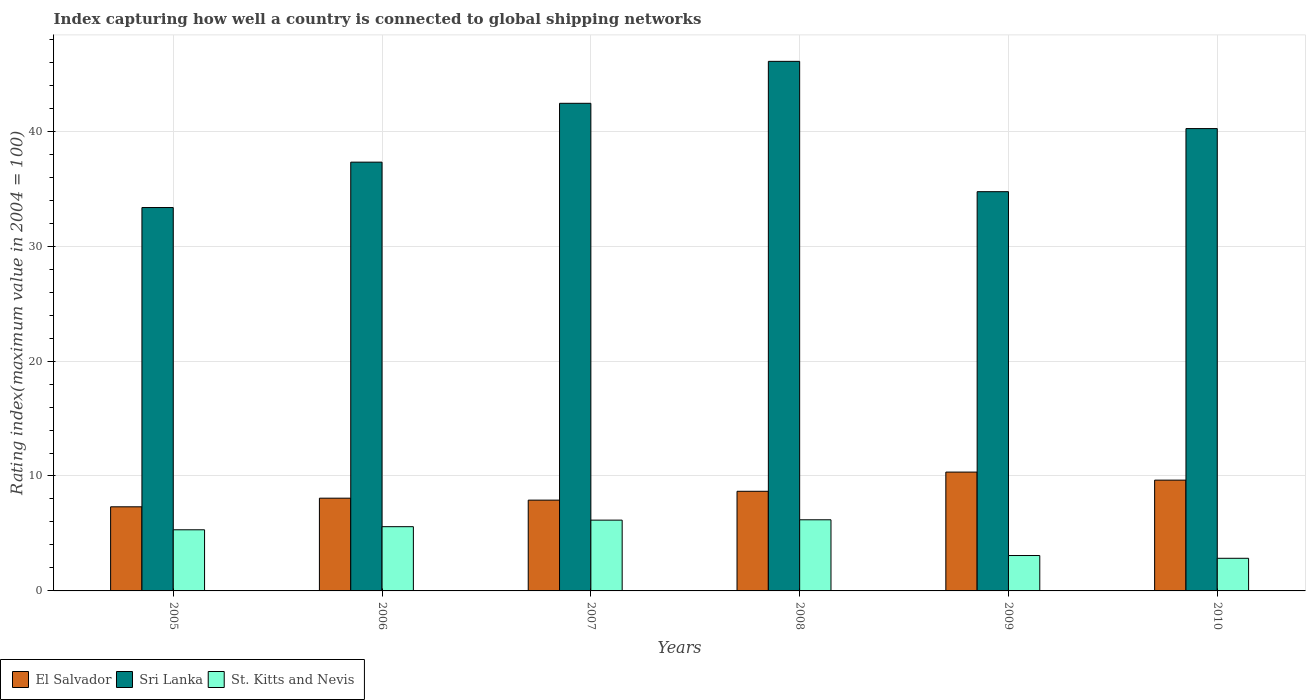How many different coloured bars are there?
Provide a succinct answer. 3. How many groups of bars are there?
Offer a terse response. 6. How many bars are there on the 3rd tick from the left?
Offer a terse response. 3. How many bars are there on the 1st tick from the right?
Offer a very short reply. 3. What is the label of the 1st group of bars from the left?
Make the answer very short. 2005. In how many cases, is the number of bars for a given year not equal to the number of legend labels?
Offer a terse response. 0. What is the rating index in St. Kitts and Nevis in 2008?
Provide a succinct answer. 6.19. Across all years, what is the maximum rating index in Sri Lanka?
Make the answer very short. 46.08. Across all years, what is the minimum rating index in Sri Lanka?
Make the answer very short. 33.36. In which year was the rating index in St. Kitts and Nevis maximum?
Offer a terse response. 2008. In which year was the rating index in Sri Lanka minimum?
Make the answer very short. 2005. What is the total rating index in El Salvador in the graph?
Your answer should be compact. 51.94. What is the difference between the rating index in Sri Lanka in 2009 and that in 2010?
Give a very brief answer. -5.49. What is the difference between the rating index in El Salvador in 2010 and the rating index in St. Kitts and Nevis in 2006?
Ensure brevity in your answer.  4.05. What is the average rating index in Sri Lanka per year?
Provide a short and direct response. 39.02. In the year 2008, what is the difference between the rating index in Sri Lanka and rating index in St. Kitts and Nevis?
Provide a short and direct response. 39.89. What is the ratio of the rating index in St. Kitts and Nevis in 2006 to that in 2010?
Provide a succinct answer. 1.97. Is the difference between the rating index in Sri Lanka in 2005 and 2006 greater than the difference between the rating index in St. Kitts and Nevis in 2005 and 2006?
Your answer should be compact. No. What is the difference between the highest and the second highest rating index in St. Kitts and Nevis?
Make the answer very short. 0.03. What is the difference between the highest and the lowest rating index in Sri Lanka?
Provide a succinct answer. 12.72. In how many years, is the rating index in St. Kitts and Nevis greater than the average rating index in St. Kitts and Nevis taken over all years?
Provide a succinct answer. 4. What does the 1st bar from the left in 2007 represents?
Ensure brevity in your answer.  El Salvador. What does the 3rd bar from the right in 2009 represents?
Provide a short and direct response. El Salvador. How many bars are there?
Offer a terse response. 18. Are all the bars in the graph horizontal?
Offer a terse response. No. Are the values on the major ticks of Y-axis written in scientific E-notation?
Keep it short and to the point. No. Does the graph contain any zero values?
Provide a succinct answer. No. How many legend labels are there?
Provide a short and direct response. 3. What is the title of the graph?
Offer a terse response. Index capturing how well a country is connected to global shipping networks. What is the label or title of the Y-axis?
Give a very brief answer. Rating index(maximum value in 2004 = 100). What is the Rating index(maximum value in 2004 = 100) in El Salvador in 2005?
Offer a very short reply. 7.32. What is the Rating index(maximum value in 2004 = 100) in Sri Lanka in 2005?
Make the answer very short. 33.36. What is the Rating index(maximum value in 2004 = 100) in St. Kitts and Nevis in 2005?
Keep it short and to the point. 5.32. What is the Rating index(maximum value in 2004 = 100) in El Salvador in 2006?
Make the answer very short. 8.07. What is the Rating index(maximum value in 2004 = 100) in Sri Lanka in 2006?
Offer a very short reply. 37.31. What is the Rating index(maximum value in 2004 = 100) in St. Kitts and Nevis in 2006?
Provide a short and direct response. 5.59. What is the Rating index(maximum value in 2004 = 100) of Sri Lanka in 2007?
Your answer should be very brief. 42.43. What is the Rating index(maximum value in 2004 = 100) in St. Kitts and Nevis in 2007?
Give a very brief answer. 6.16. What is the Rating index(maximum value in 2004 = 100) in El Salvador in 2008?
Give a very brief answer. 8.67. What is the Rating index(maximum value in 2004 = 100) in Sri Lanka in 2008?
Give a very brief answer. 46.08. What is the Rating index(maximum value in 2004 = 100) of St. Kitts and Nevis in 2008?
Give a very brief answer. 6.19. What is the Rating index(maximum value in 2004 = 100) in El Salvador in 2009?
Offer a very short reply. 10.34. What is the Rating index(maximum value in 2004 = 100) in Sri Lanka in 2009?
Your answer should be compact. 34.74. What is the Rating index(maximum value in 2004 = 100) of St. Kitts and Nevis in 2009?
Your answer should be compact. 3.08. What is the Rating index(maximum value in 2004 = 100) in El Salvador in 2010?
Ensure brevity in your answer.  9.64. What is the Rating index(maximum value in 2004 = 100) of Sri Lanka in 2010?
Keep it short and to the point. 40.23. What is the Rating index(maximum value in 2004 = 100) in St. Kitts and Nevis in 2010?
Offer a very short reply. 2.84. Across all years, what is the maximum Rating index(maximum value in 2004 = 100) in El Salvador?
Your answer should be compact. 10.34. Across all years, what is the maximum Rating index(maximum value in 2004 = 100) of Sri Lanka?
Offer a very short reply. 46.08. Across all years, what is the maximum Rating index(maximum value in 2004 = 100) in St. Kitts and Nevis?
Your response must be concise. 6.19. Across all years, what is the minimum Rating index(maximum value in 2004 = 100) in El Salvador?
Offer a terse response. 7.32. Across all years, what is the minimum Rating index(maximum value in 2004 = 100) in Sri Lanka?
Give a very brief answer. 33.36. Across all years, what is the minimum Rating index(maximum value in 2004 = 100) in St. Kitts and Nevis?
Give a very brief answer. 2.84. What is the total Rating index(maximum value in 2004 = 100) in El Salvador in the graph?
Offer a very short reply. 51.94. What is the total Rating index(maximum value in 2004 = 100) of Sri Lanka in the graph?
Provide a succinct answer. 234.15. What is the total Rating index(maximum value in 2004 = 100) in St. Kitts and Nevis in the graph?
Provide a short and direct response. 29.18. What is the difference between the Rating index(maximum value in 2004 = 100) of El Salvador in 2005 and that in 2006?
Provide a succinct answer. -0.75. What is the difference between the Rating index(maximum value in 2004 = 100) in Sri Lanka in 2005 and that in 2006?
Give a very brief answer. -3.95. What is the difference between the Rating index(maximum value in 2004 = 100) of St. Kitts and Nevis in 2005 and that in 2006?
Offer a very short reply. -0.27. What is the difference between the Rating index(maximum value in 2004 = 100) of El Salvador in 2005 and that in 2007?
Offer a very short reply. -0.58. What is the difference between the Rating index(maximum value in 2004 = 100) in Sri Lanka in 2005 and that in 2007?
Make the answer very short. -9.07. What is the difference between the Rating index(maximum value in 2004 = 100) of St. Kitts and Nevis in 2005 and that in 2007?
Offer a very short reply. -0.84. What is the difference between the Rating index(maximum value in 2004 = 100) in El Salvador in 2005 and that in 2008?
Offer a terse response. -1.35. What is the difference between the Rating index(maximum value in 2004 = 100) of Sri Lanka in 2005 and that in 2008?
Give a very brief answer. -12.72. What is the difference between the Rating index(maximum value in 2004 = 100) of St. Kitts and Nevis in 2005 and that in 2008?
Your response must be concise. -0.87. What is the difference between the Rating index(maximum value in 2004 = 100) in El Salvador in 2005 and that in 2009?
Offer a very short reply. -3.02. What is the difference between the Rating index(maximum value in 2004 = 100) of Sri Lanka in 2005 and that in 2009?
Give a very brief answer. -1.38. What is the difference between the Rating index(maximum value in 2004 = 100) in St. Kitts and Nevis in 2005 and that in 2009?
Ensure brevity in your answer.  2.24. What is the difference between the Rating index(maximum value in 2004 = 100) in El Salvador in 2005 and that in 2010?
Your answer should be very brief. -2.32. What is the difference between the Rating index(maximum value in 2004 = 100) in Sri Lanka in 2005 and that in 2010?
Provide a succinct answer. -6.87. What is the difference between the Rating index(maximum value in 2004 = 100) in St. Kitts and Nevis in 2005 and that in 2010?
Provide a succinct answer. 2.48. What is the difference between the Rating index(maximum value in 2004 = 100) in El Salvador in 2006 and that in 2007?
Your response must be concise. 0.17. What is the difference between the Rating index(maximum value in 2004 = 100) in Sri Lanka in 2006 and that in 2007?
Your answer should be compact. -5.12. What is the difference between the Rating index(maximum value in 2004 = 100) of St. Kitts and Nevis in 2006 and that in 2007?
Offer a very short reply. -0.57. What is the difference between the Rating index(maximum value in 2004 = 100) of El Salvador in 2006 and that in 2008?
Give a very brief answer. -0.6. What is the difference between the Rating index(maximum value in 2004 = 100) of Sri Lanka in 2006 and that in 2008?
Your response must be concise. -8.77. What is the difference between the Rating index(maximum value in 2004 = 100) of St. Kitts and Nevis in 2006 and that in 2008?
Give a very brief answer. -0.6. What is the difference between the Rating index(maximum value in 2004 = 100) of El Salvador in 2006 and that in 2009?
Your response must be concise. -2.27. What is the difference between the Rating index(maximum value in 2004 = 100) in Sri Lanka in 2006 and that in 2009?
Give a very brief answer. 2.57. What is the difference between the Rating index(maximum value in 2004 = 100) in St. Kitts and Nevis in 2006 and that in 2009?
Provide a short and direct response. 2.51. What is the difference between the Rating index(maximum value in 2004 = 100) in El Salvador in 2006 and that in 2010?
Your answer should be compact. -1.57. What is the difference between the Rating index(maximum value in 2004 = 100) in Sri Lanka in 2006 and that in 2010?
Your answer should be very brief. -2.92. What is the difference between the Rating index(maximum value in 2004 = 100) in St. Kitts and Nevis in 2006 and that in 2010?
Offer a very short reply. 2.75. What is the difference between the Rating index(maximum value in 2004 = 100) of El Salvador in 2007 and that in 2008?
Keep it short and to the point. -0.77. What is the difference between the Rating index(maximum value in 2004 = 100) in Sri Lanka in 2007 and that in 2008?
Ensure brevity in your answer.  -3.65. What is the difference between the Rating index(maximum value in 2004 = 100) in St. Kitts and Nevis in 2007 and that in 2008?
Your answer should be compact. -0.03. What is the difference between the Rating index(maximum value in 2004 = 100) of El Salvador in 2007 and that in 2009?
Your answer should be very brief. -2.44. What is the difference between the Rating index(maximum value in 2004 = 100) of Sri Lanka in 2007 and that in 2009?
Keep it short and to the point. 7.69. What is the difference between the Rating index(maximum value in 2004 = 100) in St. Kitts and Nevis in 2007 and that in 2009?
Offer a terse response. 3.08. What is the difference between the Rating index(maximum value in 2004 = 100) of El Salvador in 2007 and that in 2010?
Your response must be concise. -1.74. What is the difference between the Rating index(maximum value in 2004 = 100) in Sri Lanka in 2007 and that in 2010?
Provide a short and direct response. 2.2. What is the difference between the Rating index(maximum value in 2004 = 100) in St. Kitts and Nevis in 2007 and that in 2010?
Make the answer very short. 3.32. What is the difference between the Rating index(maximum value in 2004 = 100) of El Salvador in 2008 and that in 2009?
Keep it short and to the point. -1.67. What is the difference between the Rating index(maximum value in 2004 = 100) of Sri Lanka in 2008 and that in 2009?
Offer a terse response. 11.34. What is the difference between the Rating index(maximum value in 2004 = 100) in St. Kitts and Nevis in 2008 and that in 2009?
Your answer should be compact. 3.11. What is the difference between the Rating index(maximum value in 2004 = 100) of El Salvador in 2008 and that in 2010?
Make the answer very short. -0.97. What is the difference between the Rating index(maximum value in 2004 = 100) in Sri Lanka in 2008 and that in 2010?
Give a very brief answer. 5.85. What is the difference between the Rating index(maximum value in 2004 = 100) of St. Kitts and Nevis in 2008 and that in 2010?
Offer a very short reply. 3.35. What is the difference between the Rating index(maximum value in 2004 = 100) in El Salvador in 2009 and that in 2010?
Your response must be concise. 0.7. What is the difference between the Rating index(maximum value in 2004 = 100) of Sri Lanka in 2009 and that in 2010?
Your answer should be compact. -5.49. What is the difference between the Rating index(maximum value in 2004 = 100) of St. Kitts and Nevis in 2009 and that in 2010?
Offer a terse response. 0.24. What is the difference between the Rating index(maximum value in 2004 = 100) of El Salvador in 2005 and the Rating index(maximum value in 2004 = 100) of Sri Lanka in 2006?
Your answer should be compact. -29.99. What is the difference between the Rating index(maximum value in 2004 = 100) in El Salvador in 2005 and the Rating index(maximum value in 2004 = 100) in St. Kitts and Nevis in 2006?
Offer a terse response. 1.73. What is the difference between the Rating index(maximum value in 2004 = 100) in Sri Lanka in 2005 and the Rating index(maximum value in 2004 = 100) in St. Kitts and Nevis in 2006?
Your response must be concise. 27.77. What is the difference between the Rating index(maximum value in 2004 = 100) in El Salvador in 2005 and the Rating index(maximum value in 2004 = 100) in Sri Lanka in 2007?
Give a very brief answer. -35.11. What is the difference between the Rating index(maximum value in 2004 = 100) of El Salvador in 2005 and the Rating index(maximum value in 2004 = 100) of St. Kitts and Nevis in 2007?
Provide a short and direct response. 1.16. What is the difference between the Rating index(maximum value in 2004 = 100) of Sri Lanka in 2005 and the Rating index(maximum value in 2004 = 100) of St. Kitts and Nevis in 2007?
Keep it short and to the point. 27.2. What is the difference between the Rating index(maximum value in 2004 = 100) in El Salvador in 2005 and the Rating index(maximum value in 2004 = 100) in Sri Lanka in 2008?
Provide a short and direct response. -38.76. What is the difference between the Rating index(maximum value in 2004 = 100) in El Salvador in 2005 and the Rating index(maximum value in 2004 = 100) in St. Kitts and Nevis in 2008?
Ensure brevity in your answer.  1.13. What is the difference between the Rating index(maximum value in 2004 = 100) in Sri Lanka in 2005 and the Rating index(maximum value in 2004 = 100) in St. Kitts and Nevis in 2008?
Your answer should be very brief. 27.17. What is the difference between the Rating index(maximum value in 2004 = 100) in El Salvador in 2005 and the Rating index(maximum value in 2004 = 100) in Sri Lanka in 2009?
Provide a short and direct response. -27.42. What is the difference between the Rating index(maximum value in 2004 = 100) in El Salvador in 2005 and the Rating index(maximum value in 2004 = 100) in St. Kitts and Nevis in 2009?
Offer a very short reply. 4.24. What is the difference between the Rating index(maximum value in 2004 = 100) of Sri Lanka in 2005 and the Rating index(maximum value in 2004 = 100) of St. Kitts and Nevis in 2009?
Your response must be concise. 30.28. What is the difference between the Rating index(maximum value in 2004 = 100) in El Salvador in 2005 and the Rating index(maximum value in 2004 = 100) in Sri Lanka in 2010?
Your answer should be very brief. -32.91. What is the difference between the Rating index(maximum value in 2004 = 100) in El Salvador in 2005 and the Rating index(maximum value in 2004 = 100) in St. Kitts and Nevis in 2010?
Provide a short and direct response. 4.48. What is the difference between the Rating index(maximum value in 2004 = 100) in Sri Lanka in 2005 and the Rating index(maximum value in 2004 = 100) in St. Kitts and Nevis in 2010?
Ensure brevity in your answer.  30.52. What is the difference between the Rating index(maximum value in 2004 = 100) in El Salvador in 2006 and the Rating index(maximum value in 2004 = 100) in Sri Lanka in 2007?
Ensure brevity in your answer.  -34.36. What is the difference between the Rating index(maximum value in 2004 = 100) in El Salvador in 2006 and the Rating index(maximum value in 2004 = 100) in St. Kitts and Nevis in 2007?
Provide a succinct answer. 1.91. What is the difference between the Rating index(maximum value in 2004 = 100) in Sri Lanka in 2006 and the Rating index(maximum value in 2004 = 100) in St. Kitts and Nevis in 2007?
Provide a succinct answer. 31.15. What is the difference between the Rating index(maximum value in 2004 = 100) in El Salvador in 2006 and the Rating index(maximum value in 2004 = 100) in Sri Lanka in 2008?
Your response must be concise. -38.01. What is the difference between the Rating index(maximum value in 2004 = 100) of El Salvador in 2006 and the Rating index(maximum value in 2004 = 100) of St. Kitts and Nevis in 2008?
Your response must be concise. 1.88. What is the difference between the Rating index(maximum value in 2004 = 100) of Sri Lanka in 2006 and the Rating index(maximum value in 2004 = 100) of St. Kitts and Nevis in 2008?
Give a very brief answer. 31.12. What is the difference between the Rating index(maximum value in 2004 = 100) of El Salvador in 2006 and the Rating index(maximum value in 2004 = 100) of Sri Lanka in 2009?
Give a very brief answer. -26.67. What is the difference between the Rating index(maximum value in 2004 = 100) of El Salvador in 2006 and the Rating index(maximum value in 2004 = 100) of St. Kitts and Nevis in 2009?
Offer a very short reply. 4.99. What is the difference between the Rating index(maximum value in 2004 = 100) of Sri Lanka in 2006 and the Rating index(maximum value in 2004 = 100) of St. Kitts and Nevis in 2009?
Your response must be concise. 34.23. What is the difference between the Rating index(maximum value in 2004 = 100) of El Salvador in 2006 and the Rating index(maximum value in 2004 = 100) of Sri Lanka in 2010?
Give a very brief answer. -32.16. What is the difference between the Rating index(maximum value in 2004 = 100) in El Salvador in 2006 and the Rating index(maximum value in 2004 = 100) in St. Kitts and Nevis in 2010?
Make the answer very short. 5.23. What is the difference between the Rating index(maximum value in 2004 = 100) in Sri Lanka in 2006 and the Rating index(maximum value in 2004 = 100) in St. Kitts and Nevis in 2010?
Make the answer very short. 34.47. What is the difference between the Rating index(maximum value in 2004 = 100) of El Salvador in 2007 and the Rating index(maximum value in 2004 = 100) of Sri Lanka in 2008?
Your answer should be very brief. -38.18. What is the difference between the Rating index(maximum value in 2004 = 100) in El Salvador in 2007 and the Rating index(maximum value in 2004 = 100) in St. Kitts and Nevis in 2008?
Your response must be concise. 1.71. What is the difference between the Rating index(maximum value in 2004 = 100) of Sri Lanka in 2007 and the Rating index(maximum value in 2004 = 100) of St. Kitts and Nevis in 2008?
Make the answer very short. 36.24. What is the difference between the Rating index(maximum value in 2004 = 100) in El Salvador in 2007 and the Rating index(maximum value in 2004 = 100) in Sri Lanka in 2009?
Your answer should be very brief. -26.84. What is the difference between the Rating index(maximum value in 2004 = 100) of El Salvador in 2007 and the Rating index(maximum value in 2004 = 100) of St. Kitts and Nevis in 2009?
Ensure brevity in your answer.  4.82. What is the difference between the Rating index(maximum value in 2004 = 100) of Sri Lanka in 2007 and the Rating index(maximum value in 2004 = 100) of St. Kitts and Nevis in 2009?
Give a very brief answer. 39.35. What is the difference between the Rating index(maximum value in 2004 = 100) in El Salvador in 2007 and the Rating index(maximum value in 2004 = 100) in Sri Lanka in 2010?
Provide a short and direct response. -32.33. What is the difference between the Rating index(maximum value in 2004 = 100) in El Salvador in 2007 and the Rating index(maximum value in 2004 = 100) in St. Kitts and Nevis in 2010?
Keep it short and to the point. 5.06. What is the difference between the Rating index(maximum value in 2004 = 100) in Sri Lanka in 2007 and the Rating index(maximum value in 2004 = 100) in St. Kitts and Nevis in 2010?
Give a very brief answer. 39.59. What is the difference between the Rating index(maximum value in 2004 = 100) in El Salvador in 2008 and the Rating index(maximum value in 2004 = 100) in Sri Lanka in 2009?
Your response must be concise. -26.07. What is the difference between the Rating index(maximum value in 2004 = 100) in El Salvador in 2008 and the Rating index(maximum value in 2004 = 100) in St. Kitts and Nevis in 2009?
Keep it short and to the point. 5.59. What is the difference between the Rating index(maximum value in 2004 = 100) of Sri Lanka in 2008 and the Rating index(maximum value in 2004 = 100) of St. Kitts and Nevis in 2009?
Ensure brevity in your answer.  43. What is the difference between the Rating index(maximum value in 2004 = 100) in El Salvador in 2008 and the Rating index(maximum value in 2004 = 100) in Sri Lanka in 2010?
Ensure brevity in your answer.  -31.56. What is the difference between the Rating index(maximum value in 2004 = 100) in El Salvador in 2008 and the Rating index(maximum value in 2004 = 100) in St. Kitts and Nevis in 2010?
Ensure brevity in your answer.  5.83. What is the difference between the Rating index(maximum value in 2004 = 100) in Sri Lanka in 2008 and the Rating index(maximum value in 2004 = 100) in St. Kitts and Nevis in 2010?
Make the answer very short. 43.24. What is the difference between the Rating index(maximum value in 2004 = 100) of El Salvador in 2009 and the Rating index(maximum value in 2004 = 100) of Sri Lanka in 2010?
Your response must be concise. -29.89. What is the difference between the Rating index(maximum value in 2004 = 100) in Sri Lanka in 2009 and the Rating index(maximum value in 2004 = 100) in St. Kitts and Nevis in 2010?
Offer a very short reply. 31.9. What is the average Rating index(maximum value in 2004 = 100) in El Salvador per year?
Your answer should be compact. 8.66. What is the average Rating index(maximum value in 2004 = 100) in Sri Lanka per year?
Your answer should be compact. 39.02. What is the average Rating index(maximum value in 2004 = 100) of St. Kitts and Nevis per year?
Keep it short and to the point. 4.86. In the year 2005, what is the difference between the Rating index(maximum value in 2004 = 100) of El Salvador and Rating index(maximum value in 2004 = 100) of Sri Lanka?
Offer a very short reply. -26.04. In the year 2005, what is the difference between the Rating index(maximum value in 2004 = 100) in El Salvador and Rating index(maximum value in 2004 = 100) in St. Kitts and Nevis?
Your answer should be very brief. 2. In the year 2005, what is the difference between the Rating index(maximum value in 2004 = 100) in Sri Lanka and Rating index(maximum value in 2004 = 100) in St. Kitts and Nevis?
Keep it short and to the point. 28.04. In the year 2006, what is the difference between the Rating index(maximum value in 2004 = 100) in El Salvador and Rating index(maximum value in 2004 = 100) in Sri Lanka?
Offer a very short reply. -29.24. In the year 2006, what is the difference between the Rating index(maximum value in 2004 = 100) of El Salvador and Rating index(maximum value in 2004 = 100) of St. Kitts and Nevis?
Make the answer very short. 2.48. In the year 2006, what is the difference between the Rating index(maximum value in 2004 = 100) in Sri Lanka and Rating index(maximum value in 2004 = 100) in St. Kitts and Nevis?
Make the answer very short. 31.72. In the year 2007, what is the difference between the Rating index(maximum value in 2004 = 100) in El Salvador and Rating index(maximum value in 2004 = 100) in Sri Lanka?
Offer a very short reply. -34.53. In the year 2007, what is the difference between the Rating index(maximum value in 2004 = 100) of El Salvador and Rating index(maximum value in 2004 = 100) of St. Kitts and Nevis?
Ensure brevity in your answer.  1.74. In the year 2007, what is the difference between the Rating index(maximum value in 2004 = 100) in Sri Lanka and Rating index(maximum value in 2004 = 100) in St. Kitts and Nevis?
Ensure brevity in your answer.  36.27. In the year 2008, what is the difference between the Rating index(maximum value in 2004 = 100) in El Salvador and Rating index(maximum value in 2004 = 100) in Sri Lanka?
Provide a short and direct response. -37.41. In the year 2008, what is the difference between the Rating index(maximum value in 2004 = 100) of El Salvador and Rating index(maximum value in 2004 = 100) of St. Kitts and Nevis?
Make the answer very short. 2.48. In the year 2008, what is the difference between the Rating index(maximum value in 2004 = 100) in Sri Lanka and Rating index(maximum value in 2004 = 100) in St. Kitts and Nevis?
Ensure brevity in your answer.  39.89. In the year 2009, what is the difference between the Rating index(maximum value in 2004 = 100) in El Salvador and Rating index(maximum value in 2004 = 100) in Sri Lanka?
Give a very brief answer. -24.4. In the year 2009, what is the difference between the Rating index(maximum value in 2004 = 100) of El Salvador and Rating index(maximum value in 2004 = 100) of St. Kitts and Nevis?
Provide a succinct answer. 7.26. In the year 2009, what is the difference between the Rating index(maximum value in 2004 = 100) of Sri Lanka and Rating index(maximum value in 2004 = 100) of St. Kitts and Nevis?
Provide a succinct answer. 31.66. In the year 2010, what is the difference between the Rating index(maximum value in 2004 = 100) of El Salvador and Rating index(maximum value in 2004 = 100) of Sri Lanka?
Provide a short and direct response. -30.59. In the year 2010, what is the difference between the Rating index(maximum value in 2004 = 100) in Sri Lanka and Rating index(maximum value in 2004 = 100) in St. Kitts and Nevis?
Ensure brevity in your answer.  37.39. What is the ratio of the Rating index(maximum value in 2004 = 100) in El Salvador in 2005 to that in 2006?
Offer a terse response. 0.91. What is the ratio of the Rating index(maximum value in 2004 = 100) in Sri Lanka in 2005 to that in 2006?
Your response must be concise. 0.89. What is the ratio of the Rating index(maximum value in 2004 = 100) in St. Kitts and Nevis in 2005 to that in 2006?
Give a very brief answer. 0.95. What is the ratio of the Rating index(maximum value in 2004 = 100) of El Salvador in 2005 to that in 2007?
Your answer should be compact. 0.93. What is the ratio of the Rating index(maximum value in 2004 = 100) in Sri Lanka in 2005 to that in 2007?
Provide a succinct answer. 0.79. What is the ratio of the Rating index(maximum value in 2004 = 100) in St. Kitts and Nevis in 2005 to that in 2007?
Make the answer very short. 0.86. What is the ratio of the Rating index(maximum value in 2004 = 100) of El Salvador in 2005 to that in 2008?
Offer a very short reply. 0.84. What is the ratio of the Rating index(maximum value in 2004 = 100) in Sri Lanka in 2005 to that in 2008?
Your answer should be compact. 0.72. What is the ratio of the Rating index(maximum value in 2004 = 100) in St. Kitts and Nevis in 2005 to that in 2008?
Make the answer very short. 0.86. What is the ratio of the Rating index(maximum value in 2004 = 100) in El Salvador in 2005 to that in 2009?
Your response must be concise. 0.71. What is the ratio of the Rating index(maximum value in 2004 = 100) of Sri Lanka in 2005 to that in 2009?
Make the answer very short. 0.96. What is the ratio of the Rating index(maximum value in 2004 = 100) of St. Kitts and Nevis in 2005 to that in 2009?
Offer a very short reply. 1.73. What is the ratio of the Rating index(maximum value in 2004 = 100) in El Salvador in 2005 to that in 2010?
Your answer should be compact. 0.76. What is the ratio of the Rating index(maximum value in 2004 = 100) of Sri Lanka in 2005 to that in 2010?
Give a very brief answer. 0.83. What is the ratio of the Rating index(maximum value in 2004 = 100) of St. Kitts and Nevis in 2005 to that in 2010?
Ensure brevity in your answer.  1.87. What is the ratio of the Rating index(maximum value in 2004 = 100) in El Salvador in 2006 to that in 2007?
Ensure brevity in your answer.  1.02. What is the ratio of the Rating index(maximum value in 2004 = 100) of Sri Lanka in 2006 to that in 2007?
Your answer should be very brief. 0.88. What is the ratio of the Rating index(maximum value in 2004 = 100) in St. Kitts and Nevis in 2006 to that in 2007?
Offer a very short reply. 0.91. What is the ratio of the Rating index(maximum value in 2004 = 100) in El Salvador in 2006 to that in 2008?
Offer a terse response. 0.93. What is the ratio of the Rating index(maximum value in 2004 = 100) of Sri Lanka in 2006 to that in 2008?
Make the answer very short. 0.81. What is the ratio of the Rating index(maximum value in 2004 = 100) in St. Kitts and Nevis in 2006 to that in 2008?
Ensure brevity in your answer.  0.9. What is the ratio of the Rating index(maximum value in 2004 = 100) of El Salvador in 2006 to that in 2009?
Offer a very short reply. 0.78. What is the ratio of the Rating index(maximum value in 2004 = 100) in Sri Lanka in 2006 to that in 2009?
Make the answer very short. 1.07. What is the ratio of the Rating index(maximum value in 2004 = 100) in St. Kitts and Nevis in 2006 to that in 2009?
Keep it short and to the point. 1.81. What is the ratio of the Rating index(maximum value in 2004 = 100) in El Salvador in 2006 to that in 2010?
Ensure brevity in your answer.  0.84. What is the ratio of the Rating index(maximum value in 2004 = 100) of Sri Lanka in 2006 to that in 2010?
Provide a short and direct response. 0.93. What is the ratio of the Rating index(maximum value in 2004 = 100) of St. Kitts and Nevis in 2006 to that in 2010?
Offer a very short reply. 1.97. What is the ratio of the Rating index(maximum value in 2004 = 100) of El Salvador in 2007 to that in 2008?
Make the answer very short. 0.91. What is the ratio of the Rating index(maximum value in 2004 = 100) of Sri Lanka in 2007 to that in 2008?
Ensure brevity in your answer.  0.92. What is the ratio of the Rating index(maximum value in 2004 = 100) of El Salvador in 2007 to that in 2009?
Provide a succinct answer. 0.76. What is the ratio of the Rating index(maximum value in 2004 = 100) in Sri Lanka in 2007 to that in 2009?
Offer a terse response. 1.22. What is the ratio of the Rating index(maximum value in 2004 = 100) in El Salvador in 2007 to that in 2010?
Offer a very short reply. 0.82. What is the ratio of the Rating index(maximum value in 2004 = 100) of Sri Lanka in 2007 to that in 2010?
Offer a very short reply. 1.05. What is the ratio of the Rating index(maximum value in 2004 = 100) of St. Kitts and Nevis in 2007 to that in 2010?
Offer a terse response. 2.17. What is the ratio of the Rating index(maximum value in 2004 = 100) of El Salvador in 2008 to that in 2009?
Keep it short and to the point. 0.84. What is the ratio of the Rating index(maximum value in 2004 = 100) of Sri Lanka in 2008 to that in 2009?
Offer a very short reply. 1.33. What is the ratio of the Rating index(maximum value in 2004 = 100) of St. Kitts and Nevis in 2008 to that in 2009?
Provide a short and direct response. 2.01. What is the ratio of the Rating index(maximum value in 2004 = 100) in El Salvador in 2008 to that in 2010?
Provide a short and direct response. 0.9. What is the ratio of the Rating index(maximum value in 2004 = 100) of Sri Lanka in 2008 to that in 2010?
Make the answer very short. 1.15. What is the ratio of the Rating index(maximum value in 2004 = 100) in St. Kitts and Nevis in 2008 to that in 2010?
Ensure brevity in your answer.  2.18. What is the ratio of the Rating index(maximum value in 2004 = 100) of El Salvador in 2009 to that in 2010?
Keep it short and to the point. 1.07. What is the ratio of the Rating index(maximum value in 2004 = 100) in Sri Lanka in 2009 to that in 2010?
Ensure brevity in your answer.  0.86. What is the ratio of the Rating index(maximum value in 2004 = 100) in St. Kitts and Nevis in 2009 to that in 2010?
Your answer should be compact. 1.08. What is the difference between the highest and the second highest Rating index(maximum value in 2004 = 100) in Sri Lanka?
Offer a very short reply. 3.65. What is the difference between the highest and the lowest Rating index(maximum value in 2004 = 100) in El Salvador?
Your answer should be compact. 3.02. What is the difference between the highest and the lowest Rating index(maximum value in 2004 = 100) in Sri Lanka?
Provide a short and direct response. 12.72. What is the difference between the highest and the lowest Rating index(maximum value in 2004 = 100) in St. Kitts and Nevis?
Your response must be concise. 3.35. 